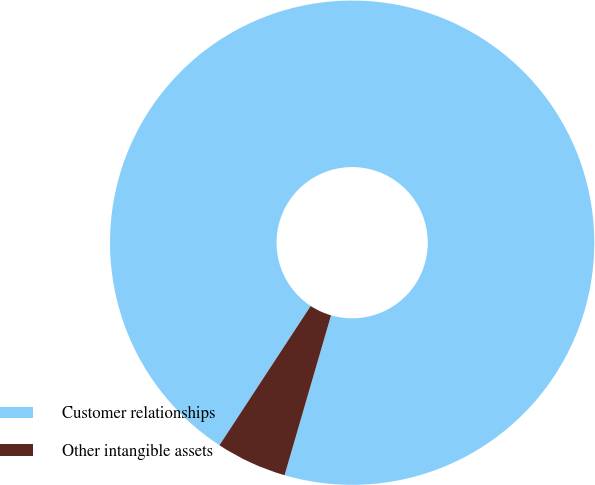<chart> <loc_0><loc_0><loc_500><loc_500><pie_chart><fcel>Customer relationships<fcel>Other intangible assets<nl><fcel>95.27%<fcel>4.73%<nl></chart> 